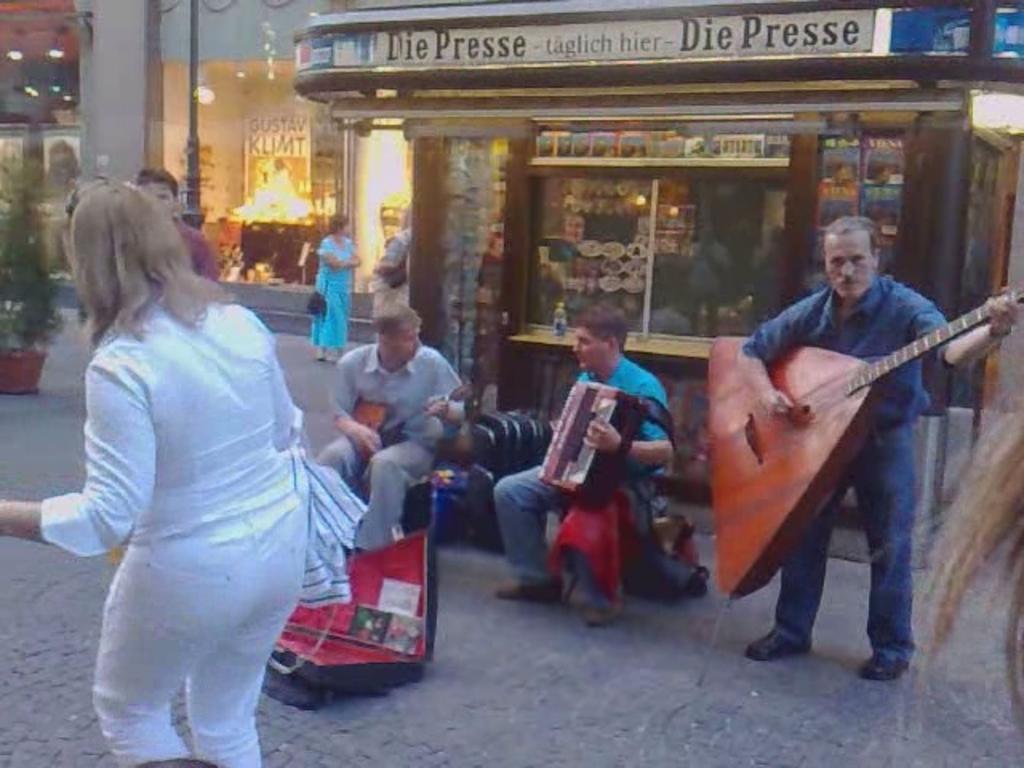Can you describe this image briefly? In the picture I can see people among them some are standing and some are sitting. The man on the right side is holding a musical instrument in hands. In the background I can see buildings, plant pots and some other objects. 